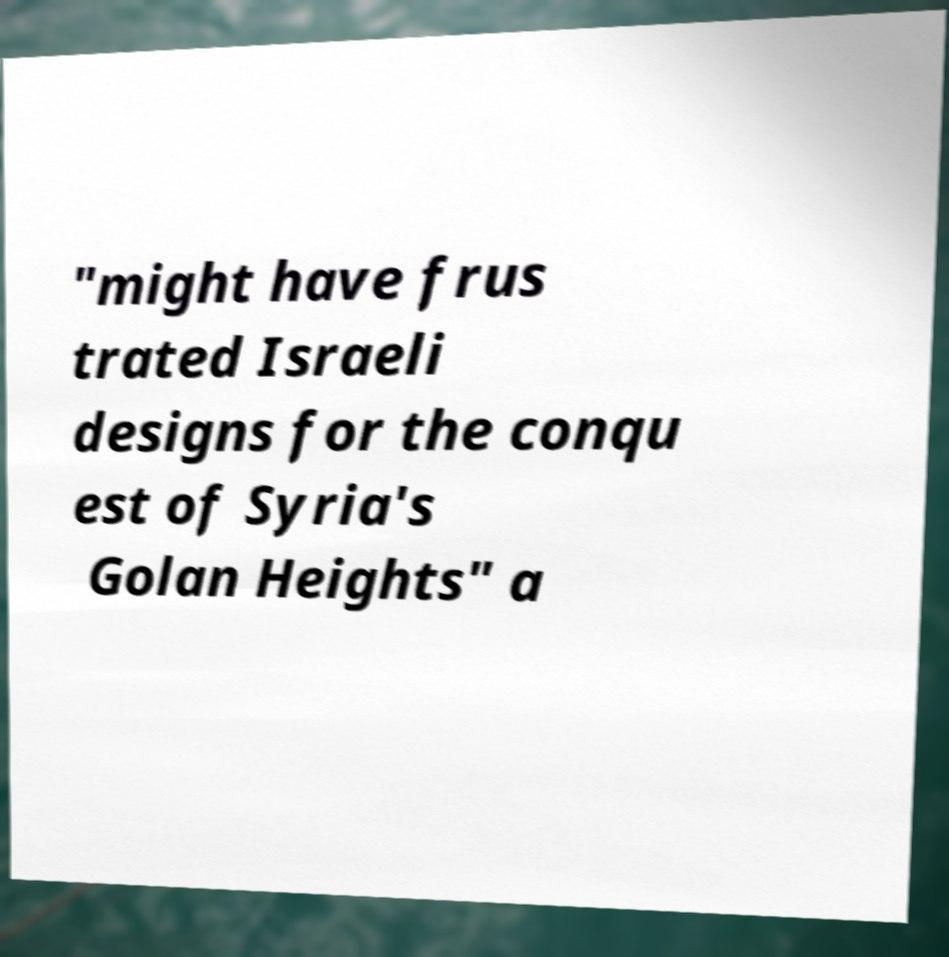Please identify and transcribe the text found in this image. "might have frus trated Israeli designs for the conqu est of Syria's Golan Heights" a 